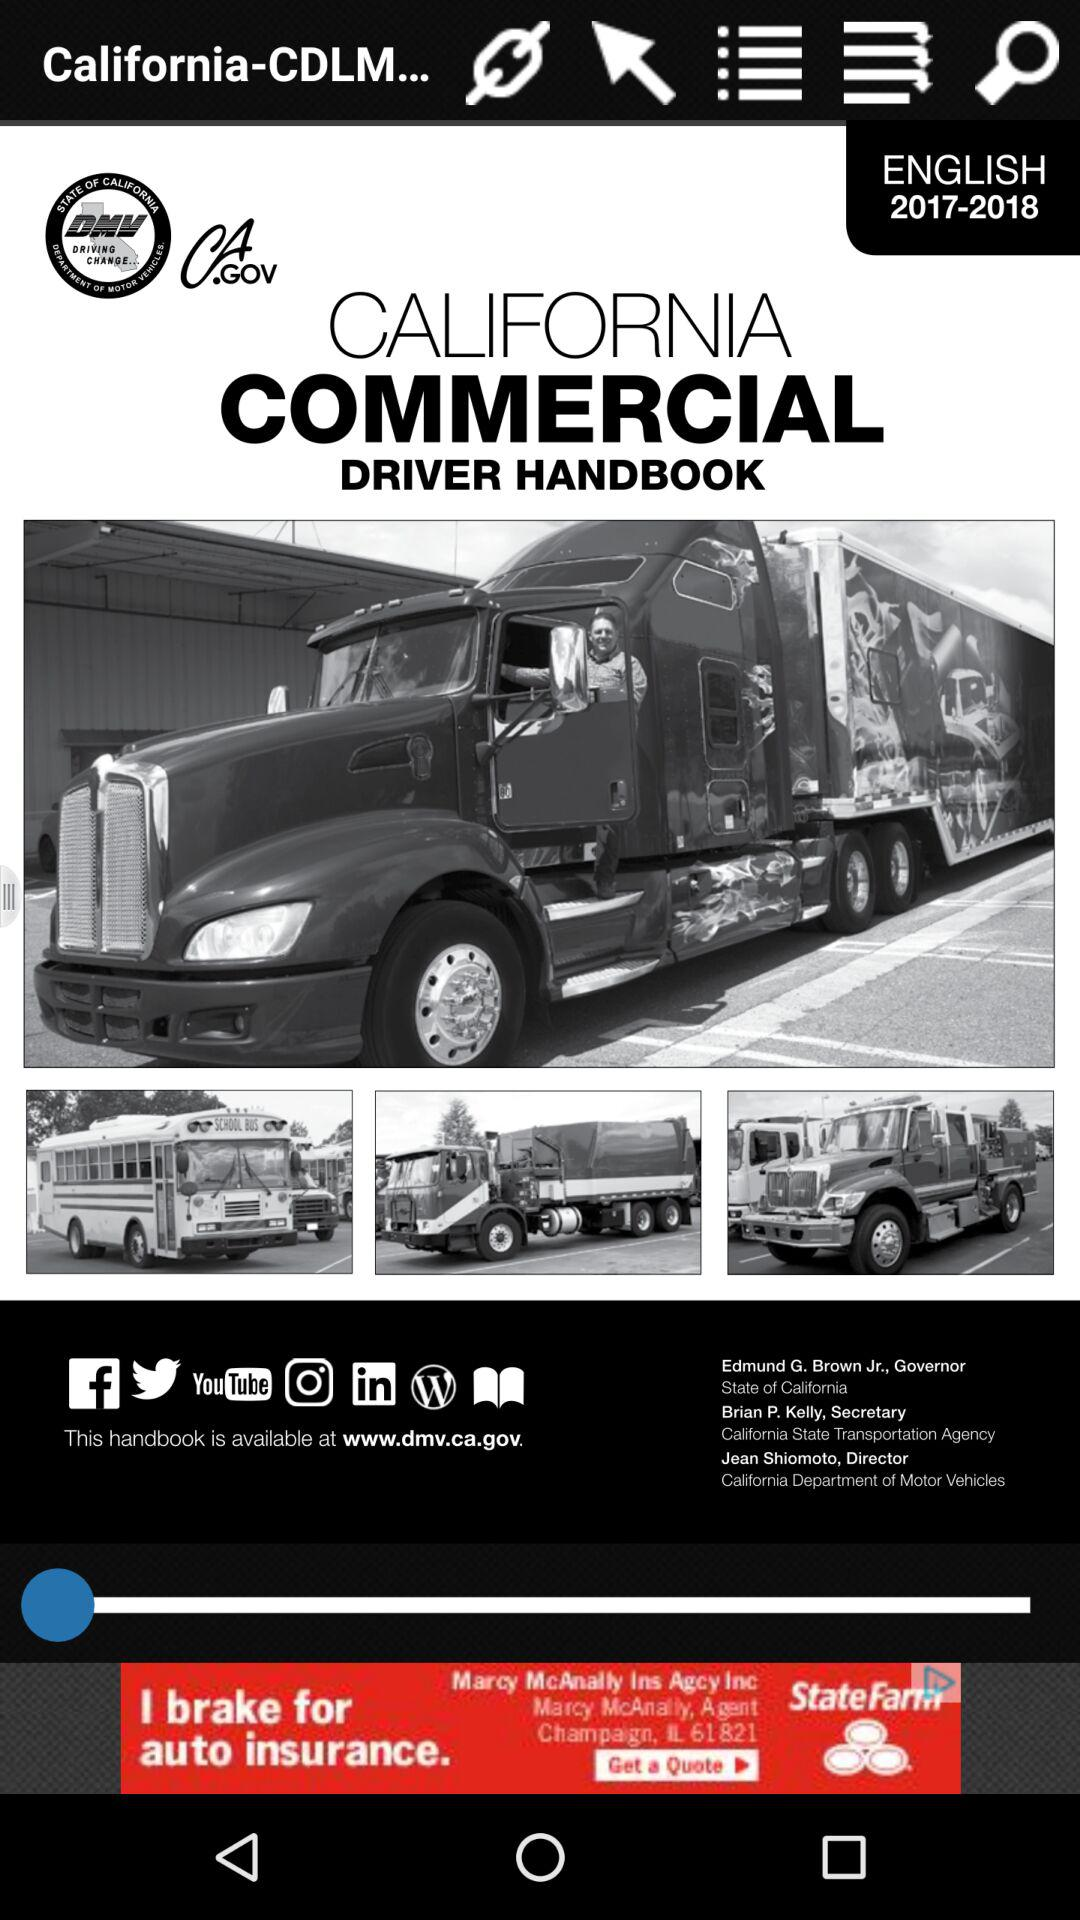What is the mentioned language? The mentioned language is English. 